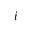<formula> <loc_0><loc_0><loc_500><loc_500>i</formula> 